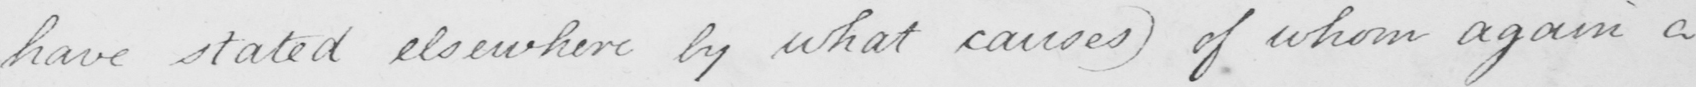What text is written in this handwritten line? have stated elsewhere by what causes )  of whom again a 